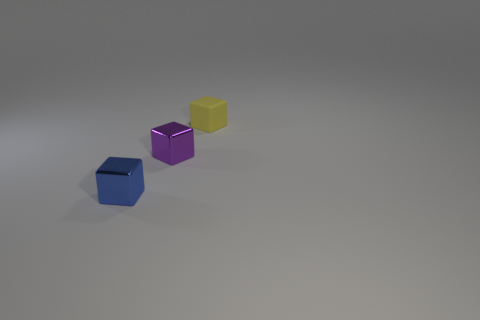What shape is the tiny object that is in front of the purple metal object behind the small blue object?
Your response must be concise. Cube. What size is the metallic cube behind the shiny cube that is in front of the metallic thing to the right of the blue cube?
Keep it short and to the point. Small. Is the size of the purple metallic cube the same as the yellow block?
Keep it short and to the point. Yes. How many things are either tiny rubber things or tiny blue objects?
Ensure brevity in your answer.  2. What size is the block in front of the metallic object behind the tiny blue shiny object?
Your response must be concise. Small. What size is the yellow matte thing?
Offer a terse response. Small. There is a object that is both left of the yellow cube and behind the blue object; what is its shape?
Provide a short and direct response. Cube. What color is the other small matte thing that is the same shape as the purple thing?
Provide a short and direct response. Yellow. What number of things are small cubes left of the small yellow thing or small metallic blocks in front of the small purple object?
Offer a terse response. 2. There is a small purple metallic thing; what shape is it?
Your response must be concise. Cube. 